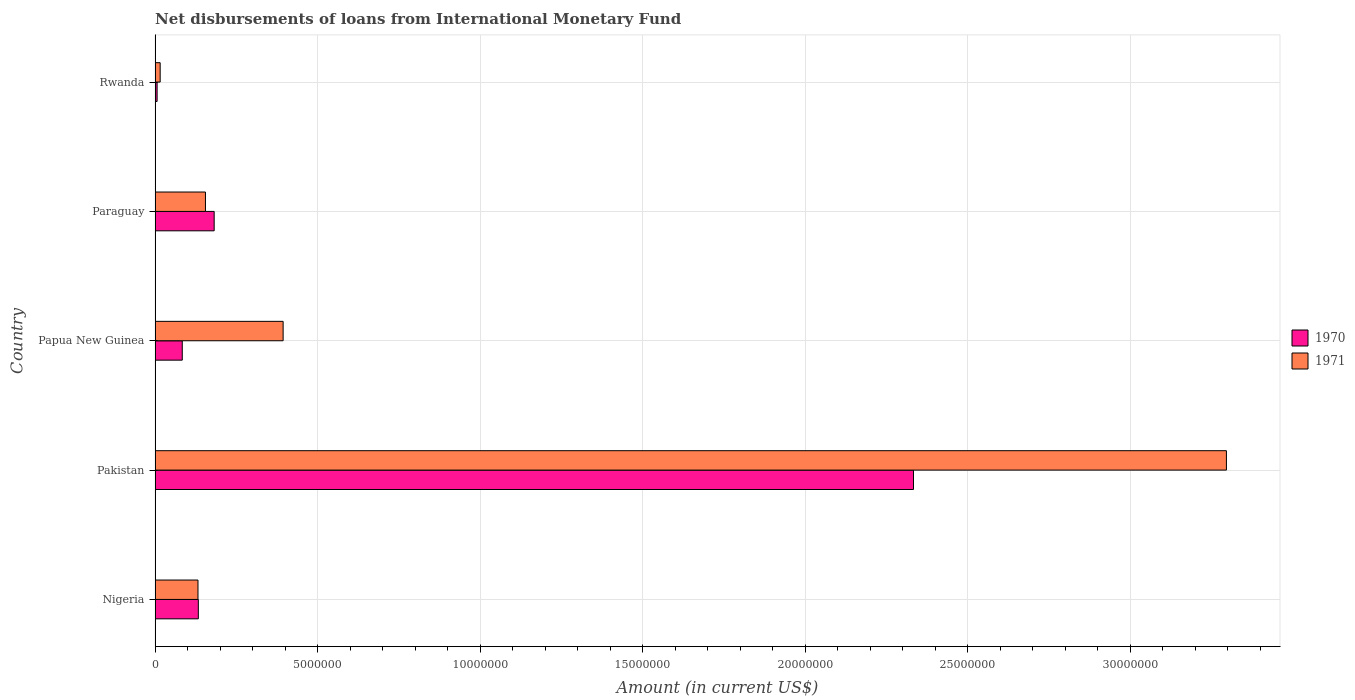Are the number of bars on each tick of the Y-axis equal?
Give a very brief answer. Yes. How many bars are there on the 3rd tick from the top?
Make the answer very short. 2. What is the label of the 5th group of bars from the top?
Ensure brevity in your answer.  Nigeria. In how many cases, is the number of bars for a given country not equal to the number of legend labels?
Your response must be concise. 0. What is the amount of loans disbursed in 1971 in Papua New Guinea?
Your answer should be compact. 3.94e+06. Across all countries, what is the maximum amount of loans disbursed in 1970?
Your answer should be very brief. 2.33e+07. Across all countries, what is the minimum amount of loans disbursed in 1971?
Make the answer very short. 1.57e+05. In which country was the amount of loans disbursed in 1971 maximum?
Provide a short and direct response. Pakistan. In which country was the amount of loans disbursed in 1970 minimum?
Offer a very short reply. Rwanda. What is the total amount of loans disbursed in 1970 in the graph?
Your response must be concise. 2.74e+07. What is the difference between the amount of loans disbursed in 1971 in Nigeria and that in Pakistan?
Make the answer very short. -3.16e+07. What is the difference between the amount of loans disbursed in 1971 in Rwanda and the amount of loans disbursed in 1970 in Papua New Guinea?
Ensure brevity in your answer.  -6.80e+05. What is the average amount of loans disbursed in 1970 per country?
Provide a succinct answer. 5.48e+06. What is the difference between the amount of loans disbursed in 1970 and amount of loans disbursed in 1971 in Pakistan?
Provide a succinct answer. -9.62e+06. What is the ratio of the amount of loans disbursed in 1970 in Nigeria to that in Rwanda?
Give a very brief answer. 21.13. Is the difference between the amount of loans disbursed in 1970 in Papua New Guinea and Rwanda greater than the difference between the amount of loans disbursed in 1971 in Papua New Guinea and Rwanda?
Offer a very short reply. No. What is the difference between the highest and the second highest amount of loans disbursed in 1971?
Make the answer very short. 2.90e+07. What is the difference between the highest and the lowest amount of loans disbursed in 1971?
Your answer should be compact. 3.28e+07. What does the 1st bar from the top in Nigeria represents?
Give a very brief answer. 1971. How many bars are there?
Give a very brief answer. 10. Are all the bars in the graph horizontal?
Your response must be concise. Yes. How many countries are there in the graph?
Offer a terse response. 5. Are the values on the major ticks of X-axis written in scientific E-notation?
Ensure brevity in your answer.  No. Does the graph contain any zero values?
Your answer should be compact. No. How are the legend labels stacked?
Give a very brief answer. Vertical. What is the title of the graph?
Ensure brevity in your answer.  Net disbursements of loans from International Monetary Fund. Does "1975" appear as one of the legend labels in the graph?
Ensure brevity in your answer.  No. What is the label or title of the X-axis?
Your answer should be compact. Amount (in current US$). What is the label or title of the Y-axis?
Provide a succinct answer. Country. What is the Amount (in current US$) of 1970 in Nigeria?
Offer a very short reply. 1.33e+06. What is the Amount (in current US$) of 1971 in Nigeria?
Ensure brevity in your answer.  1.32e+06. What is the Amount (in current US$) in 1970 in Pakistan?
Your answer should be compact. 2.33e+07. What is the Amount (in current US$) in 1971 in Pakistan?
Ensure brevity in your answer.  3.30e+07. What is the Amount (in current US$) of 1970 in Papua New Guinea?
Keep it short and to the point. 8.37e+05. What is the Amount (in current US$) in 1971 in Papua New Guinea?
Provide a short and direct response. 3.94e+06. What is the Amount (in current US$) of 1970 in Paraguay?
Make the answer very short. 1.82e+06. What is the Amount (in current US$) of 1971 in Paraguay?
Provide a short and direct response. 1.55e+06. What is the Amount (in current US$) in 1970 in Rwanda?
Give a very brief answer. 6.30e+04. What is the Amount (in current US$) in 1971 in Rwanda?
Provide a short and direct response. 1.57e+05. Across all countries, what is the maximum Amount (in current US$) in 1970?
Make the answer very short. 2.33e+07. Across all countries, what is the maximum Amount (in current US$) in 1971?
Provide a succinct answer. 3.30e+07. Across all countries, what is the minimum Amount (in current US$) of 1970?
Provide a succinct answer. 6.30e+04. Across all countries, what is the minimum Amount (in current US$) in 1971?
Provide a short and direct response. 1.57e+05. What is the total Amount (in current US$) of 1970 in the graph?
Keep it short and to the point. 2.74e+07. What is the total Amount (in current US$) of 1971 in the graph?
Offer a terse response. 3.99e+07. What is the difference between the Amount (in current US$) in 1970 in Nigeria and that in Pakistan?
Offer a very short reply. -2.20e+07. What is the difference between the Amount (in current US$) of 1971 in Nigeria and that in Pakistan?
Provide a succinct answer. -3.16e+07. What is the difference between the Amount (in current US$) in 1970 in Nigeria and that in Papua New Guinea?
Offer a very short reply. 4.94e+05. What is the difference between the Amount (in current US$) in 1971 in Nigeria and that in Papua New Guinea?
Give a very brief answer. -2.62e+06. What is the difference between the Amount (in current US$) of 1970 in Nigeria and that in Paraguay?
Provide a succinct answer. -4.87e+05. What is the difference between the Amount (in current US$) of 1970 in Nigeria and that in Rwanda?
Offer a very short reply. 1.27e+06. What is the difference between the Amount (in current US$) of 1971 in Nigeria and that in Rwanda?
Your answer should be very brief. 1.16e+06. What is the difference between the Amount (in current US$) of 1970 in Pakistan and that in Papua New Guinea?
Keep it short and to the point. 2.25e+07. What is the difference between the Amount (in current US$) in 1971 in Pakistan and that in Papua New Guinea?
Keep it short and to the point. 2.90e+07. What is the difference between the Amount (in current US$) in 1970 in Pakistan and that in Paraguay?
Offer a terse response. 2.15e+07. What is the difference between the Amount (in current US$) of 1971 in Pakistan and that in Paraguay?
Keep it short and to the point. 3.14e+07. What is the difference between the Amount (in current US$) of 1970 in Pakistan and that in Rwanda?
Your response must be concise. 2.33e+07. What is the difference between the Amount (in current US$) of 1971 in Pakistan and that in Rwanda?
Ensure brevity in your answer.  3.28e+07. What is the difference between the Amount (in current US$) of 1970 in Papua New Guinea and that in Paraguay?
Offer a very short reply. -9.81e+05. What is the difference between the Amount (in current US$) of 1971 in Papua New Guinea and that in Paraguay?
Give a very brief answer. 2.39e+06. What is the difference between the Amount (in current US$) in 1970 in Papua New Guinea and that in Rwanda?
Ensure brevity in your answer.  7.74e+05. What is the difference between the Amount (in current US$) of 1971 in Papua New Guinea and that in Rwanda?
Make the answer very short. 3.78e+06. What is the difference between the Amount (in current US$) in 1970 in Paraguay and that in Rwanda?
Your answer should be very brief. 1.76e+06. What is the difference between the Amount (in current US$) in 1971 in Paraguay and that in Rwanda?
Offer a very short reply. 1.39e+06. What is the difference between the Amount (in current US$) of 1970 in Nigeria and the Amount (in current US$) of 1971 in Pakistan?
Provide a succinct answer. -3.16e+07. What is the difference between the Amount (in current US$) in 1970 in Nigeria and the Amount (in current US$) in 1971 in Papua New Guinea?
Your answer should be compact. -2.61e+06. What is the difference between the Amount (in current US$) of 1970 in Nigeria and the Amount (in current US$) of 1971 in Paraguay?
Your response must be concise. -2.19e+05. What is the difference between the Amount (in current US$) of 1970 in Nigeria and the Amount (in current US$) of 1971 in Rwanda?
Give a very brief answer. 1.17e+06. What is the difference between the Amount (in current US$) of 1970 in Pakistan and the Amount (in current US$) of 1971 in Papua New Guinea?
Make the answer very short. 1.94e+07. What is the difference between the Amount (in current US$) in 1970 in Pakistan and the Amount (in current US$) in 1971 in Paraguay?
Offer a very short reply. 2.18e+07. What is the difference between the Amount (in current US$) of 1970 in Pakistan and the Amount (in current US$) of 1971 in Rwanda?
Your answer should be compact. 2.32e+07. What is the difference between the Amount (in current US$) in 1970 in Papua New Guinea and the Amount (in current US$) in 1971 in Paraguay?
Offer a terse response. -7.13e+05. What is the difference between the Amount (in current US$) in 1970 in Papua New Guinea and the Amount (in current US$) in 1971 in Rwanda?
Make the answer very short. 6.80e+05. What is the difference between the Amount (in current US$) of 1970 in Paraguay and the Amount (in current US$) of 1971 in Rwanda?
Provide a succinct answer. 1.66e+06. What is the average Amount (in current US$) of 1970 per country?
Your answer should be very brief. 5.48e+06. What is the average Amount (in current US$) in 1971 per country?
Your response must be concise. 7.98e+06. What is the difference between the Amount (in current US$) in 1970 and Amount (in current US$) in 1971 in Nigeria?
Offer a terse response. 1.10e+04. What is the difference between the Amount (in current US$) in 1970 and Amount (in current US$) in 1971 in Pakistan?
Make the answer very short. -9.62e+06. What is the difference between the Amount (in current US$) of 1970 and Amount (in current US$) of 1971 in Papua New Guinea?
Provide a short and direct response. -3.10e+06. What is the difference between the Amount (in current US$) in 1970 and Amount (in current US$) in 1971 in Paraguay?
Offer a terse response. 2.68e+05. What is the difference between the Amount (in current US$) of 1970 and Amount (in current US$) of 1971 in Rwanda?
Make the answer very short. -9.40e+04. What is the ratio of the Amount (in current US$) of 1970 in Nigeria to that in Pakistan?
Make the answer very short. 0.06. What is the ratio of the Amount (in current US$) of 1971 in Nigeria to that in Pakistan?
Your response must be concise. 0.04. What is the ratio of the Amount (in current US$) of 1970 in Nigeria to that in Papua New Guinea?
Offer a very short reply. 1.59. What is the ratio of the Amount (in current US$) in 1971 in Nigeria to that in Papua New Guinea?
Ensure brevity in your answer.  0.34. What is the ratio of the Amount (in current US$) in 1970 in Nigeria to that in Paraguay?
Keep it short and to the point. 0.73. What is the ratio of the Amount (in current US$) in 1971 in Nigeria to that in Paraguay?
Provide a short and direct response. 0.85. What is the ratio of the Amount (in current US$) in 1970 in Nigeria to that in Rwanda?
Give a very brief answer. 21.13. What is the ratio of the Amount (in current US$) in 1971 in Nigeria to that in Rwanda?
Your answer should be very brief. 8.41. What is the ratio of the Amount (in current US$) of 1970 in Pakistan to that in Papua New Guinea?
Provide a succinct answer. 27.87. What is the ratio of the Amount (in current US$) of 1971 in Pakistan to that in Papua New Guinea?
Your answer should be compact. 8.37. What is the ratio of the Amount (in current US$) in 1970 in Pakistan to that in Paraguay?
Ensure brevity in your answer.  12.83. What is the ratio of the Amount (in current US$) in 1971 in Pakistan to that in Paraguay?
Offer a very short reply. 21.26. What is the ratio of the Amount (in current US$) in 1970 in Pakistan to that in Rwanda?
Make the answer very short. 370.27. What is the ratio of the Amount (in current US$) in 1971 in Pakistan to that in Rwanda?
Your answer should be very brief. 209.89. What is the ratio of the Amount (in current US$) in 1970 in Papua New Guinea to that in Paraguay?
Provide a short and direct response. 0.46. What is the ratio of the Amount (in current US$) of 1971 in Papua New Guinea to that in Paraguay?
Give a very brief answer. 2.54. What is the ratio of the Amount (in current US$) in 1970 in Papua New Guinea to that in Rwanda?
Keep it short and to the point. 13.29. What is the ratio of the Amount (in current US$) in 1971 in Papua New Guinea to that in Rwanda?
Your response must be concise. 25.09. What is the ratio of the Amount (in current US$) in 1970 in Paraguay to that in Rwanda?
Give a very brief answer. 28.86. What is the ratio of the Amount (in current US$) in 1971 in Paraguay to that in Rwanda?
Make the answer very short. 9.87. What is the difference between the highest and the second highest Amount (in current US$) in 1970?
Provide a short and direct response. 2.15e+07. What is the difference between the highest and the second highest Amount (in current US$) of 1971?
Ensure brevity in your answer.  2.90e+07. What is the difference between the highest and the lowest Amount (in current US$) of 1970?
Your answer should be very brief. 2.33e+07. What is the difference between the highest and the lowest Amount (in current US$) of 1971?
Provide a short and direct response. 3.28e+07. 